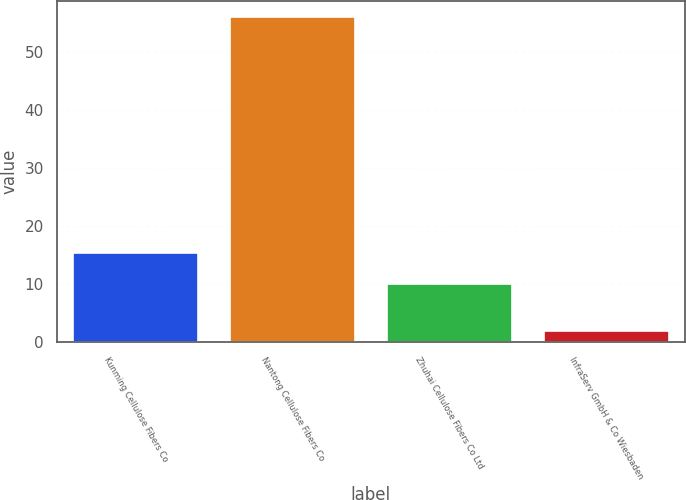Convert chart to OTSL. <chart><loc_0><loc_0><loc_500><loc_500><bar_chart><fcel>Kunming Cellulose Fibers Co<fcel>Nantong Cellulose Fibers Co<fcel>Zhuhai Cellulose Fibers Co Ltd<fcel>InfraServ GmbH & Co Wiesbaden<nl><fcel>15.4<fcel>56<fcel>10<fcel>2<nl></chart> 